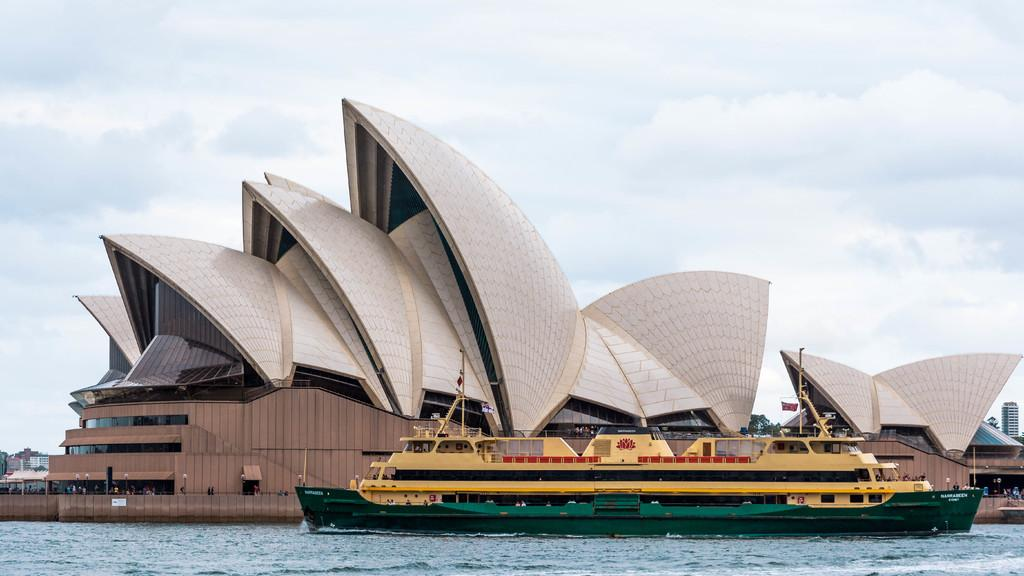What is the main subject of the image? The main subject of the image is a ship. Where is the ship located in the image? The ship is on the water. What can be seen in the background of the image? There is a building and the sky visible in the background of the image. What is the condition of the sky in the image? The sky has clouds in it. How many dogs are playing chess on the ship in the image? There are no dogs or chess games present in the image. 